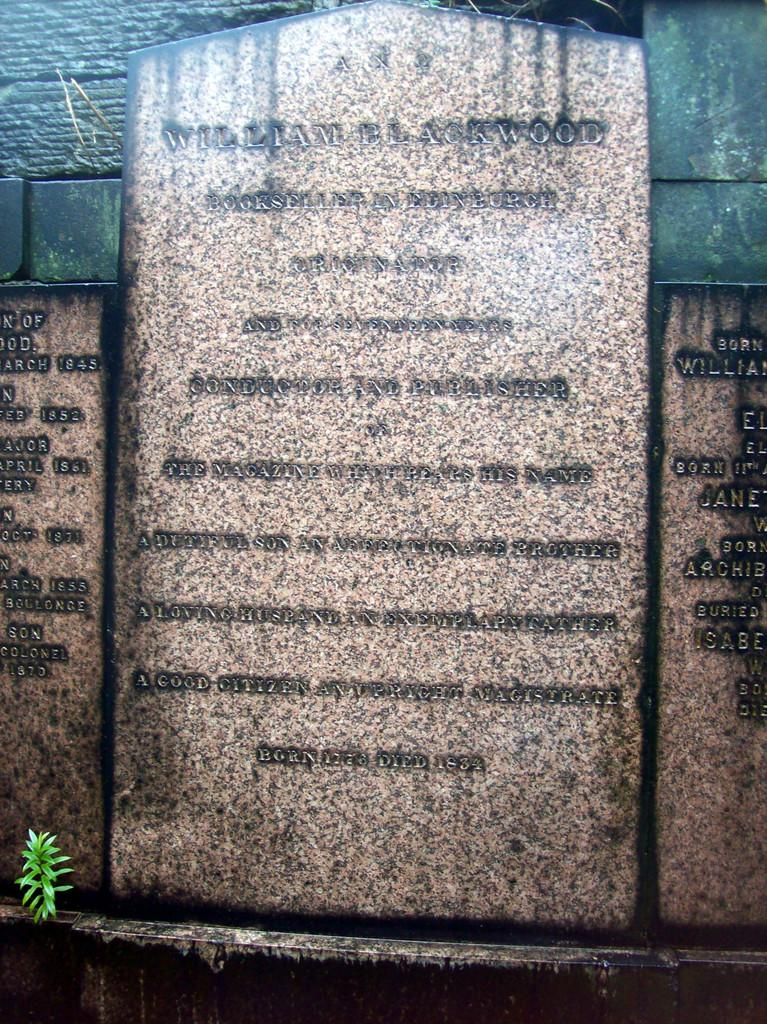What is the main subject of the image? There is a grave stone in the image. What can be found on the grave stone? There is information written on the grave stone. Are there any other stones with information in the image? Yes, there is another stone with information in the image. What color is the shirt hanging on the seashore in the image? There is no shirt or seashore present in the image; it features a grave stone and another stone with information. 